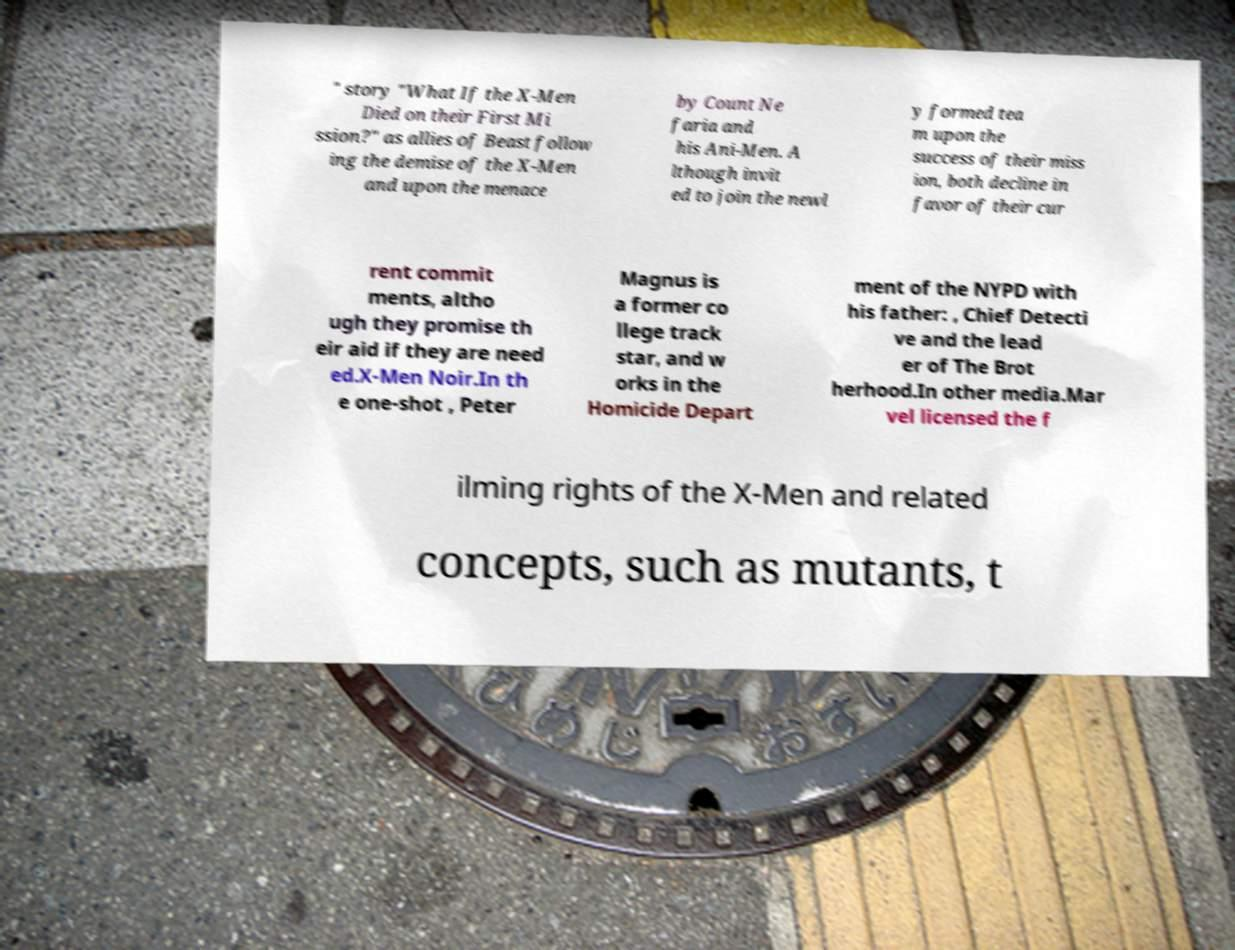Can you accurately transcribe the text from the provided image for me? " story "What If the X-Men Died on their First Mi ssion?" as allies of Beast follow ing the demise of the X-Men and upon the menace by Count Ne faria and his Ani-Men. A lthough invit ed to join the newl y formed tea m upon the success of their miss ion, both decline in favor of their cur rent commit ments, altho ugh they promise th eir aid if they are need ed.X-Men Noir.In th e one-shot , Peter Magnus is a former co llege track star, and w orks in the Homicide Depart ment of the NYPD with his father: , Chief Detecti ve and the lead er of The Brot herhood.In other media.Mar vel licensed the f ilming rights of the X-Men and related concepts, such as mutants, t 